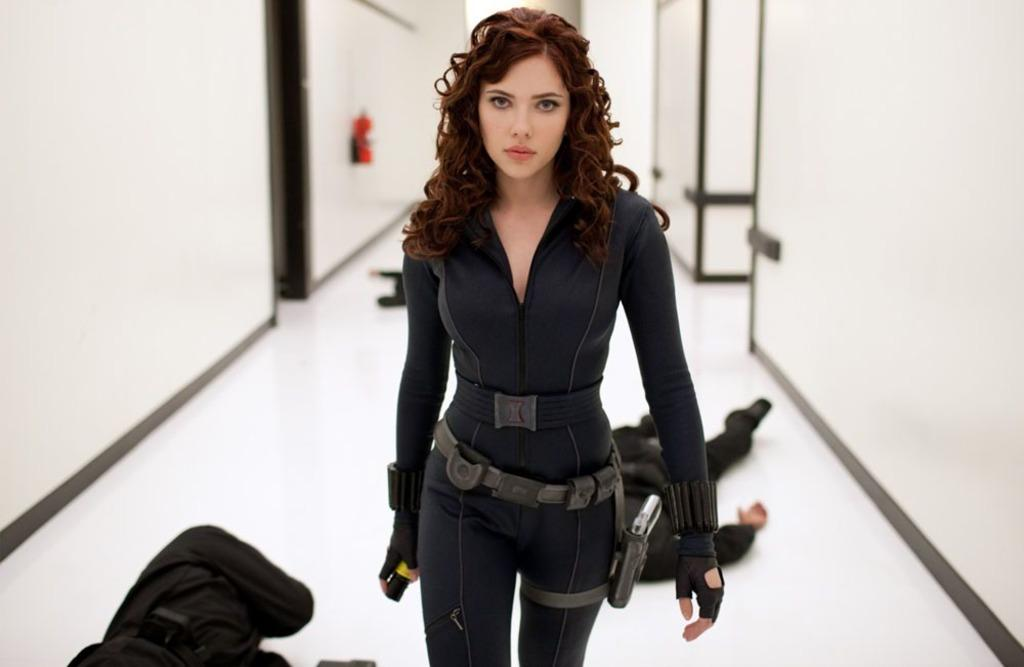Who is the main subject in the image? There is a lady in the image. What is the lady doing in the image? The lady is holding an object. What can be seen in the background of the image? There are people lying on the floor and doors visible in the background of the image. What type of map is the lady using to act in the image? There is no map present in the image, and the lady is not acting; she is simply holding an object. 